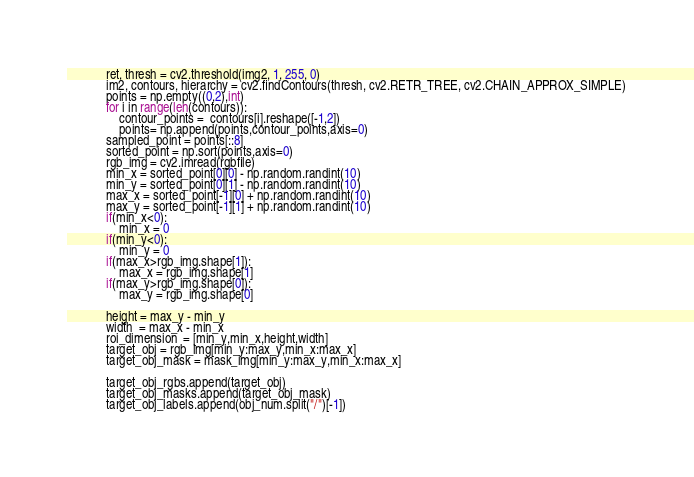Convert code to text. <code><loc_0><loc_0><loc_500><loc_500><_Python_>            ret, thresh = cv2.threshold(img2, 1, 255, 0)
            im2, contours, hierarchy = cv2.findContours(thresh, cv2.RETR_TREE, cv2.CHAIN_APPROX_SIMPLE)
            points = np.empty((0,2),int)            
            for i in range(len(contours)):    
                contour_points =  contours[i].reshape([-1,2])
                points= np.append(points,contour_points,axis=0)
            sampled_point = points[::8]
            sorted_point = np.sort(points,axis=0)
            rgb_img = cv2.imread(rgbfile)
            min_x = sorted_point[0][0] - np.random.randint(10)
            min_y = sorted_point[0][1] - np.random.randint(10)
            max_x = sorted_point[-1][0] + np.random.randint(10)
            max_y = sorted_point[-1][1] + np.random.randint(10)
            if(min_x<0):
                min_x = 0
            if(min_y<0):
                min_y = 0
            if(max_x>rgb_img.shape[1]):
                max_x = rgb_img.shape[1]
            if(max_y>rgb_img.shape[0]):
                max_y = rgb_img.shape[0]

            height = max_y - min_y
            width  = max_x - min_x
            roi_dimension  = [min_y,min_x,height,width]
            target_obj = rgb_img[min_y:max_y,min_x:max_x]
            target_obj_mask = mask_img[min_y:max_y,min_x:max_x]
            
            target_obj_rgbs.append(target_obj)
            target_obj_masks.append(target_obj_mask)
            target_obj_labels.append(obj_num.split("/")[-1])</code> 